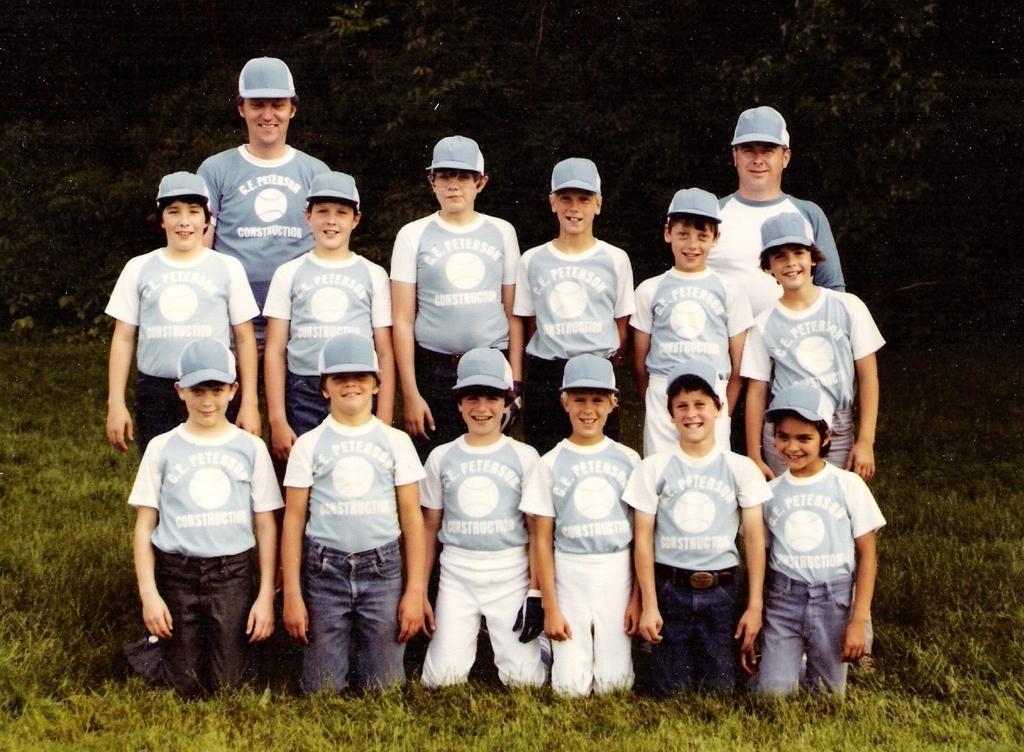In one or two sentences, can you explain what this image depicts? In this image we can see two men with smiling faces wearing caps and standing on the ground. Some boys with smiling faces, wearing caps and standing on the ground. Some boys with smiling faces, wearing caps and in a kneeling position on the ground. There are some trees in the background, some grass on the ground and the background is dark. 